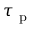Convert formula to latex. <formula><loc_0><loc_0><loc_500><loc_500>\tau _ { p }</formula> 